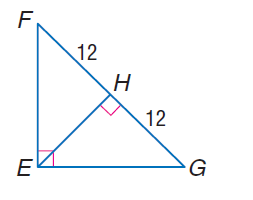Answer the mathemtical geometry problem and directly provide the correct option letter.
Question: Find the measure of the altitude drawn to the hypotenuse.
Choices: A: 6 B: 12 C: 16 D: 24 B 